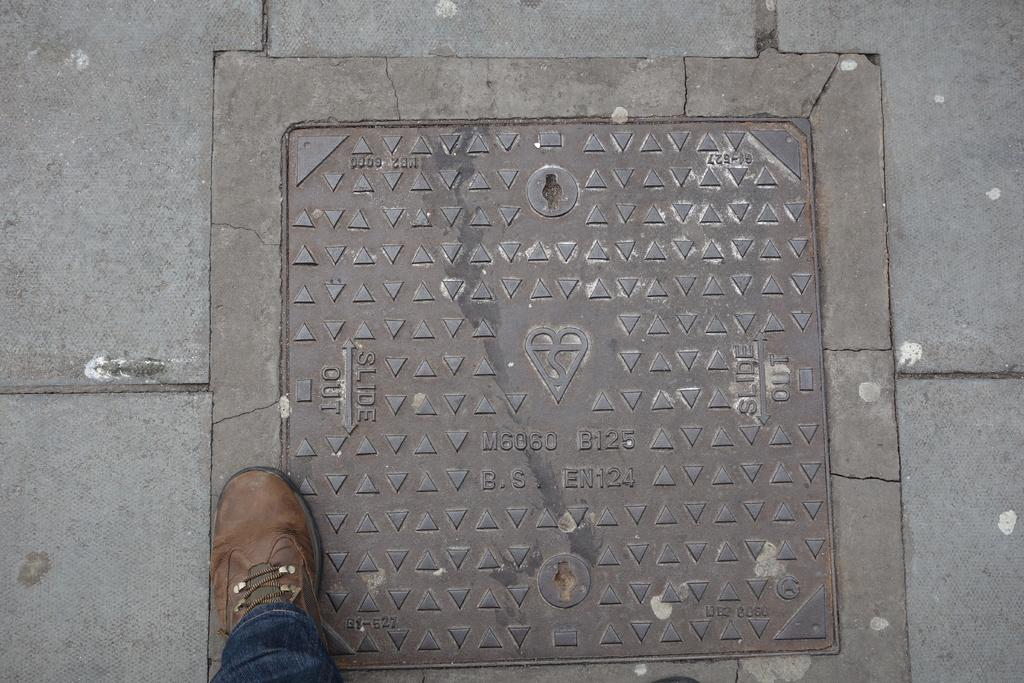What object is located at the bottom of the image? There is a shoe at the bottom of the image. What can be seen in the middle of the image? There is a steel plate attached to the floor in the middle of the image. How many toothbrushes are visible in the image? There are no toothbrushes present in the image. Is there any salt visible on the steel plate in the image? There is no salt visible on the steel plate in the image. 